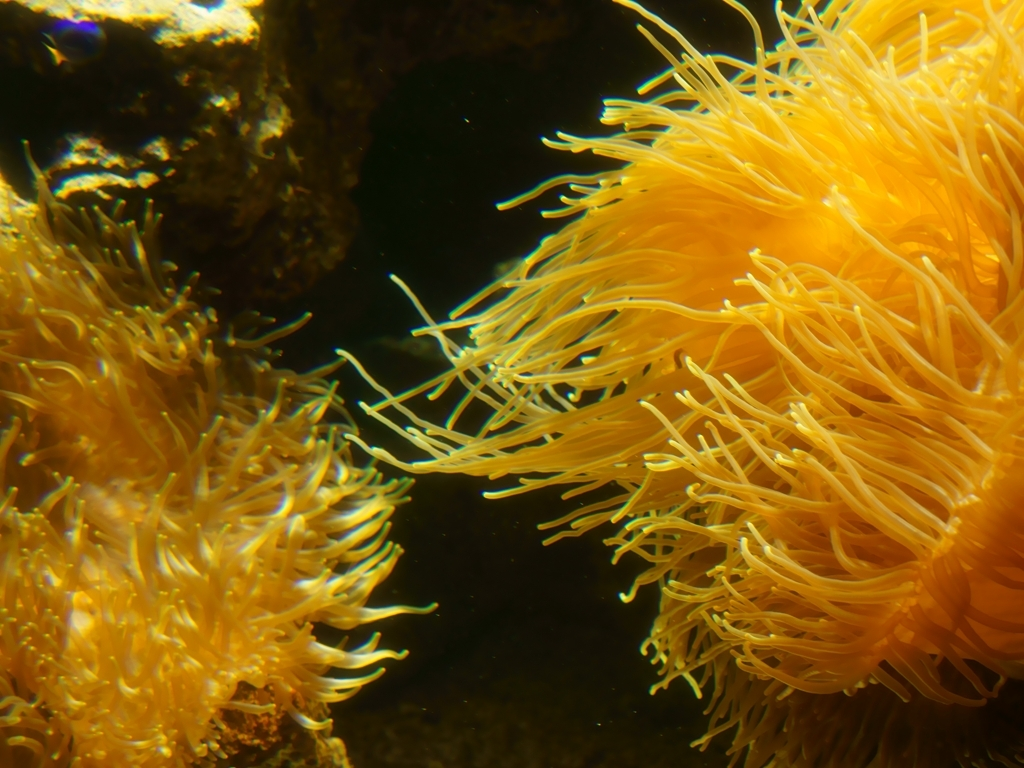Are there any quality issues with this image? The image is mostly clear with good focus and vibrant colors, specifically capturing the intricate patterns of what appears to be sea anemones. However, there is a slight blurriness at the edges and corners which slightly detracts from the overall quality. No major artifacts are present, and the image is well-composed, so it serves its purpose well if the objective is to showcase marine life. 